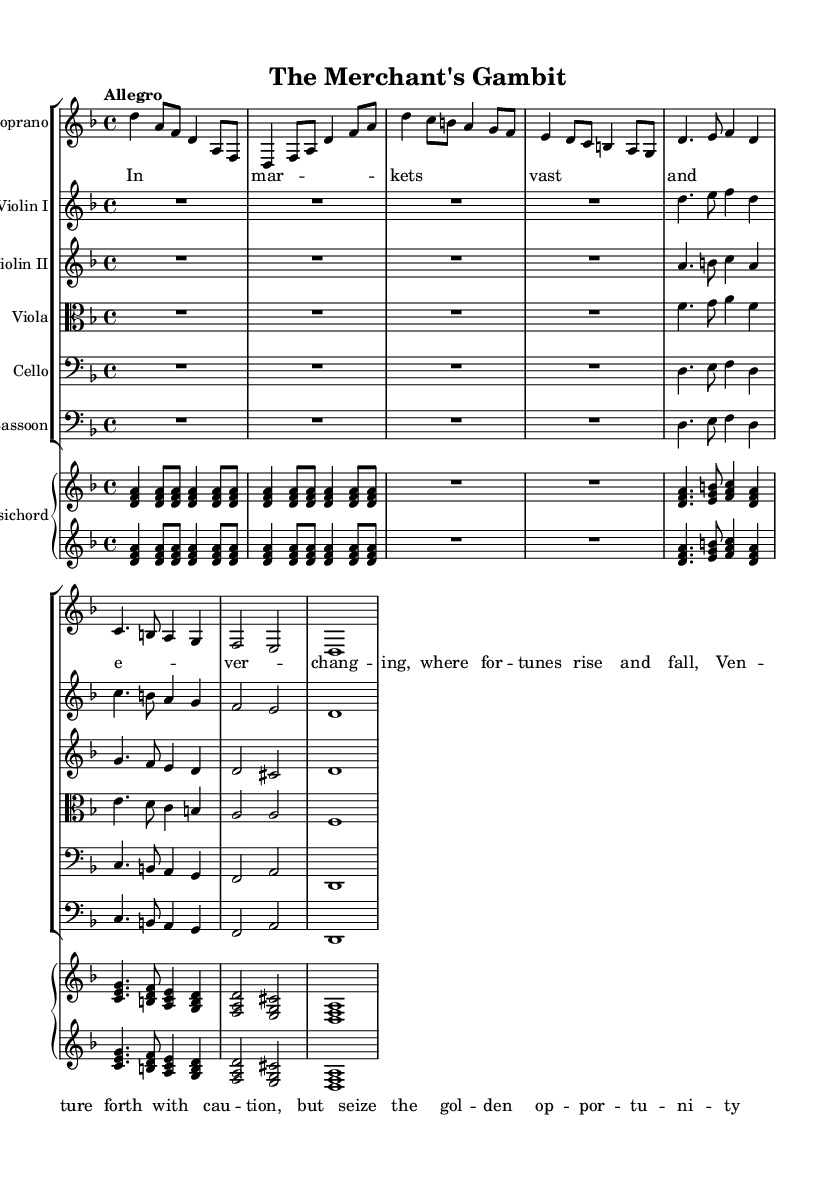What is the key signature of this music? The key signature can be identified at the beginning of the staff in the sheet music. In this case, there is one flat, which indicates that the key signature is D minor.
Answer: D minor What is the time signature of this piece? The time signature is located at the beginning of the music notation, shown after the key signature. Here, the time signature is 4/4, which means there are four beats in a measure.
Answer: 4/4 What does the tempo marking indicate for this piece? The tempo marking is stated at the beginning of the score, which is "Allegro." This term suggests a lively and fast tempo.
Answer: Allegro Which instrument plays in the alto clef? By examining the clefs used for each staff, the viola is the only instrument that is indicated to use the alto clef in this score.
Answer: Viola How many notes are in the initial introduction of the soprano part? To find the number of notes in the introduction of the soprano part, one needs to count the notes in the first measure and the subsequent measures of the introductory section. The first part consists of 6 notes (d, a, f, d, a, f).
Answer: 6 Which section includes lyrics that discuss caution in business ventures? The lyrics associated with the "Aria" section directly refer to caution and seizing opportunities as they deal with the concepts of risk and reward. The key phrase from the lyrics explicitly outlines this caution.
Answer: Aria What is the instrument that has duplicated its parts with the bass clef? Upon reviewing the staff groups, the harpsichord has both treble and bass clefs, indicating that it plays parts in both registers.
Answer: Harpsichord 